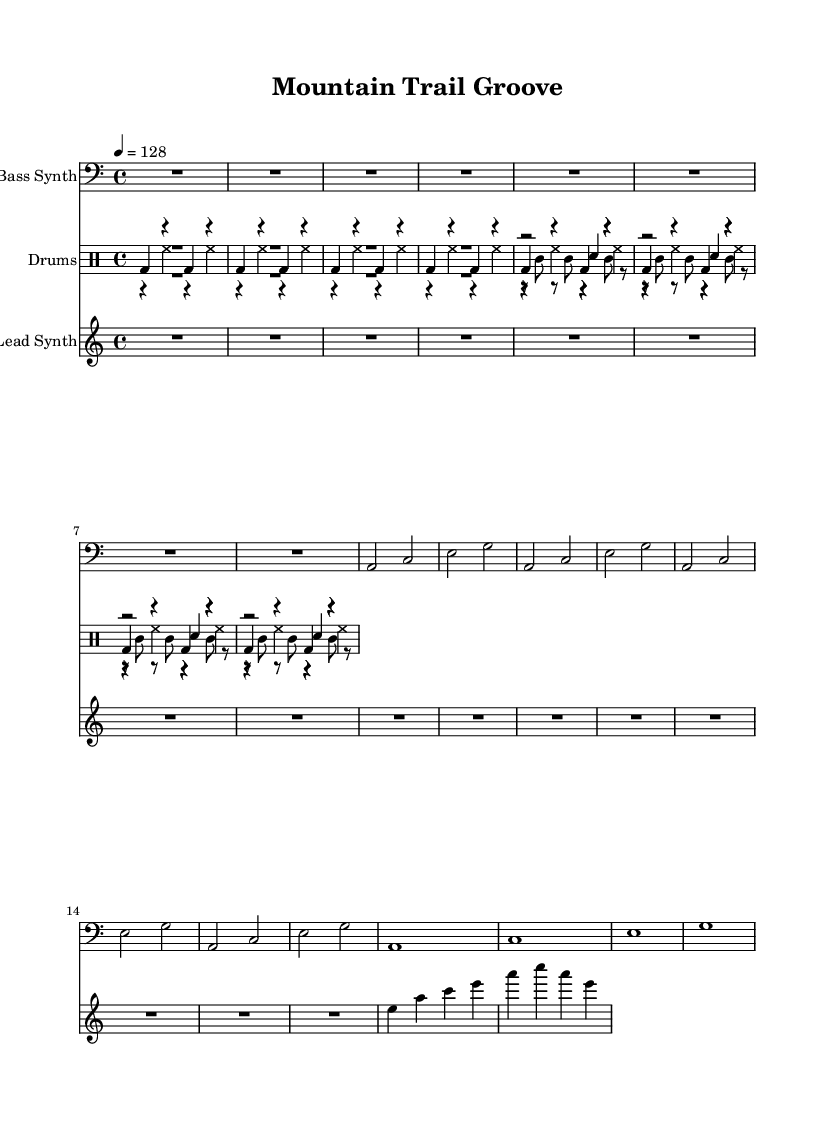What is the key signature of this music? The key signature is denoted at the beginning of the staff with the presence of one flat (B) indicating A minor.
Answer: A minor What is the time signature of the piece? The time signature appears at the start of the score, indicating four beats per measure, represented as 4/4.
Answer: 4/4 What is the tempo marking for the piece? The tempo marking indicates the beats per minute, which is set at 128, shown at the start of the score.
Answer: 128 How many different drum voices are indicated in the score? In the drum staff section, there are four distinct drum voices listed: kick drum, hi-hat, snare, and percussion.
Answer: Four What is the first note in the bass synth part? The first note in the bass synth part is represented on the staff as a rest, denoting silence before the melody begins.
Answer: Rest Which instrument plays the lead synth part? The lead synth part is marked under a separate staff labeled as "Lead Synth," indicating it's played by a synthesizer.
Answer: Lead Synth Is the bass line ascending or descending? By analyzing the sequence of notes, it's evident that the bass line has an ascending pattern starting from A to C, then E, and continuing upward.
Answer: Ascending 